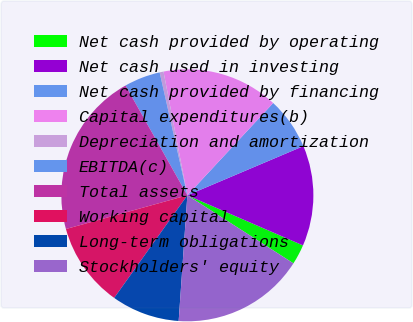<chart> <loc_0><loc_0><loc_500><loc_500><pie_chart><fcel>Net cash provided by operating<fcel>Net cash used in investing<fcel>Net cash provided by financing<fcel>Capital expenditures(b)<fcel>Depreciation and amortization<fcel>EBITDA(c)<fcel>Total assets<fcel>Working capital<fcel>Long-term obligations<fcel>Stockholders' equity<nl><fcel>2.57%<fcel>12.89%<fcel>6.7%<fcel>14.95%<fcel>0.5%<fcel>4.63%<fcel>21.15%<fcel>10.83%<fcel>8.76%<fcel>17.02%<nl></chart> 